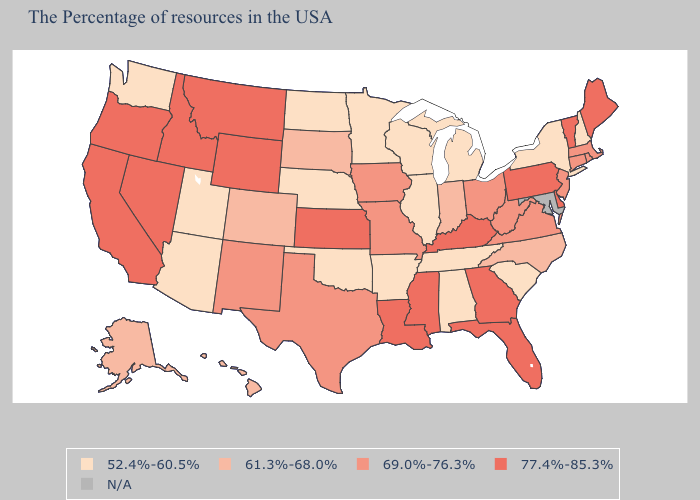What is the lowest value in states that border Montana?
Write a very short answer. 52.4%-60.5%. Among the states that border Kansas , does Missouri have the lowest value?
Short answer required. No. Which states have the highest value in the USA?
Short answer required. Maine, Vermont, Delaware, Pennsylvania, Florida, Georgia, Kentucky, Mississippi, Louisiana, Kansas, Wyoming, Montana, Idaho, Nevada, California, Oregon. What is the value of Utah?
Answer briefly. 52.4%-60.5%. Among the states that border Mississippi , which have the highest value?
Answer briefly. Louisiana. Which states have the highest value in the USA?
Concise answer only. Maine, Vermont, Delaware, Pennsylvania, Florida, Georgia, Kentucky, Mississippi, Louisiana, Kansas, Wyoming, Montana, Idaho, Nevada, California, Oregon. Which states have the highest value in the USA?
Write a very short answer. Maine, Vermont, Delaware, Pennsylvania, Florida, Georgia, Kentucky, Mississippi, Louisiana, Kansas, Wyoming, Montana, Idaho, Nevada, California, Oregon. Among the states that border Wisconsin , does Iowa have the lowest value?
Keep it brief. No. What is the highest value in the USA?
Quick response, please. 77.4%-85.3%. Name the states that have a value in the range 61.3%-68.0%?
Write a very short answer. North Carolina, Indiana, South Dakota, Colorado, Alaska, Hawaii. What is the lowest value in states that border Montana?
Give a very brief answer. 52.4%-60.5%. What is the value of Florida?
Short answer required. 77.4%-85.3%. Which states have the highest value in the USA?
Short answer required. Maine, Vermont, Delaware, Pennsylvania, Florida, Georgia, Kentucky, Mississippi, Louisiana, Kansas, Wyoming, Montana, Idaho, Nevada, California, Oregon. What is the value of Illinois?
Short answer required. 52.4%-60.5%. 